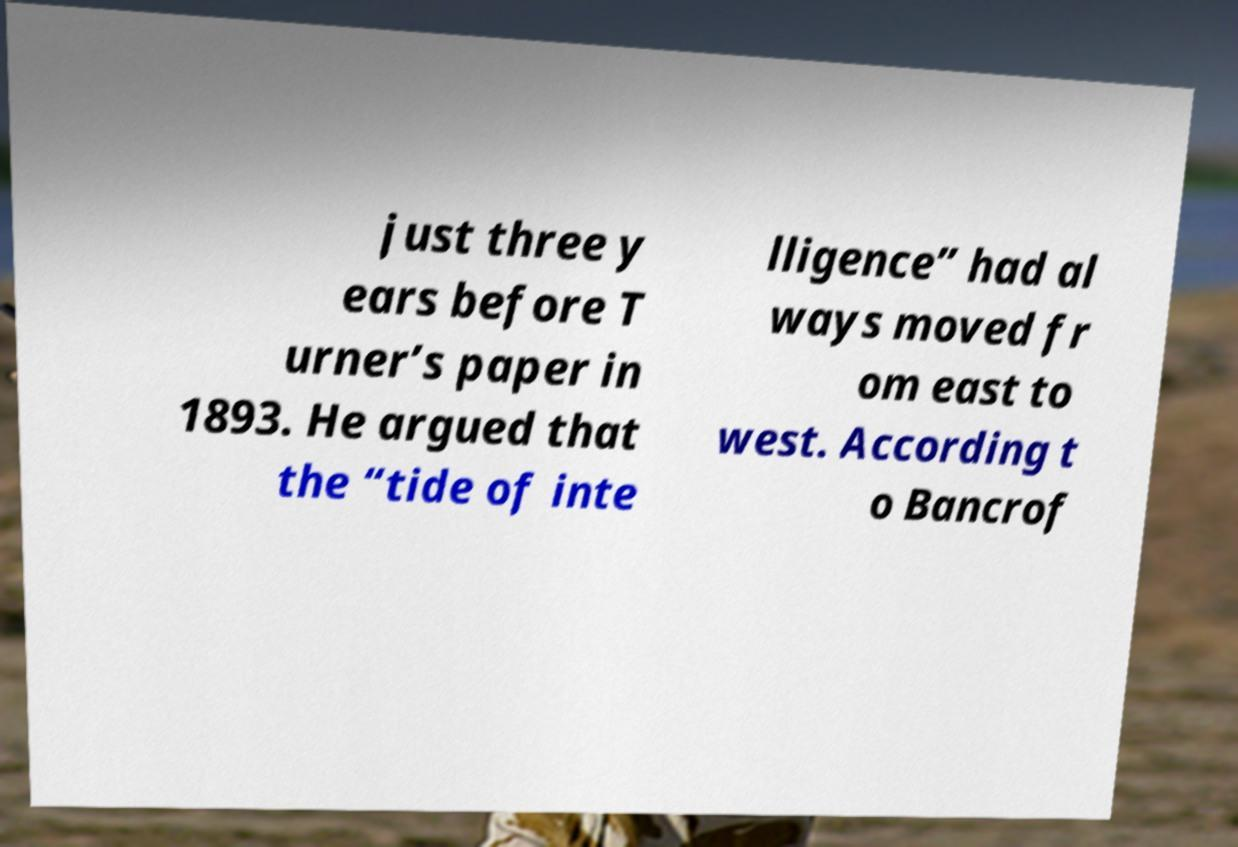Please read and relay the text visible in this image. What does it say? just three y ears before T urner’s paper in 1893. He argued that the “tide of inte lligence” had al ways moved fr om east to west. According t o Bancrof 